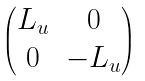Convert formula to latex. <formula><loc_0><loc_0><loc_500><loc_500>\begin{pmatrix} L _ { u } & 0 \\ 0 & - L _ { u } \end{pmatrix}</formula> 